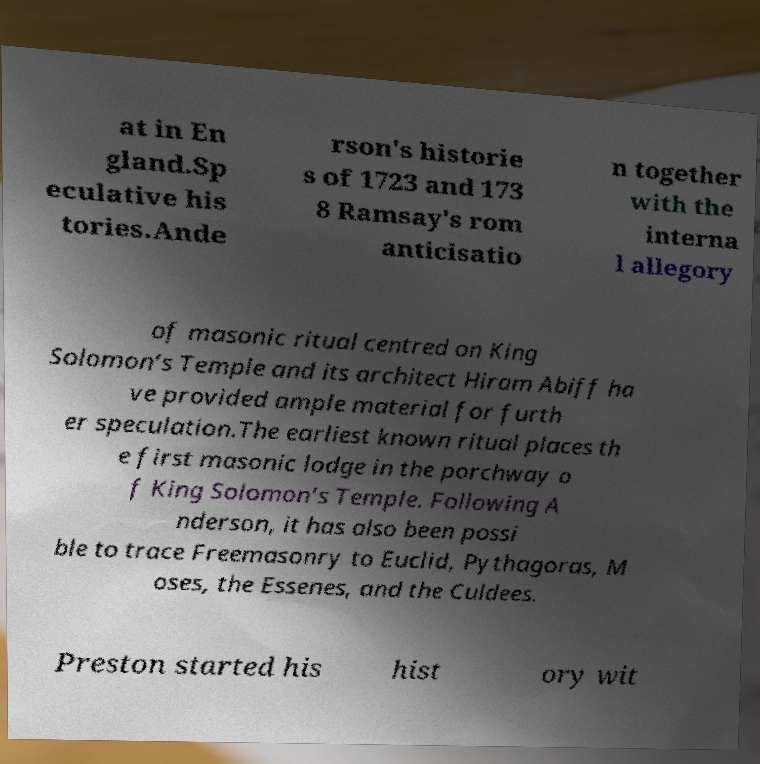There's text embedded in this image that I need extracted. Can you transcribe it verbatim? at in En gland.Sp eculative his tories.Ande rson's historie s of 1723 and 173 8 Ramsay's rom anticisatio n together with the interna l allegory of masonic ritual centred on King Solomon’s Temple and its architect Hiram Abiff ha ve provided ample material for furth er speculation.The earliest known ritual places th e first masonic lodge in the porchway o f King Solomon’s Temple. Following A nderson, it has also been possi ble to trace Freemasonry to Euclid, Pythagoras, M oses, the Essenes, and the Culdees. Preston started his hist ory wit 